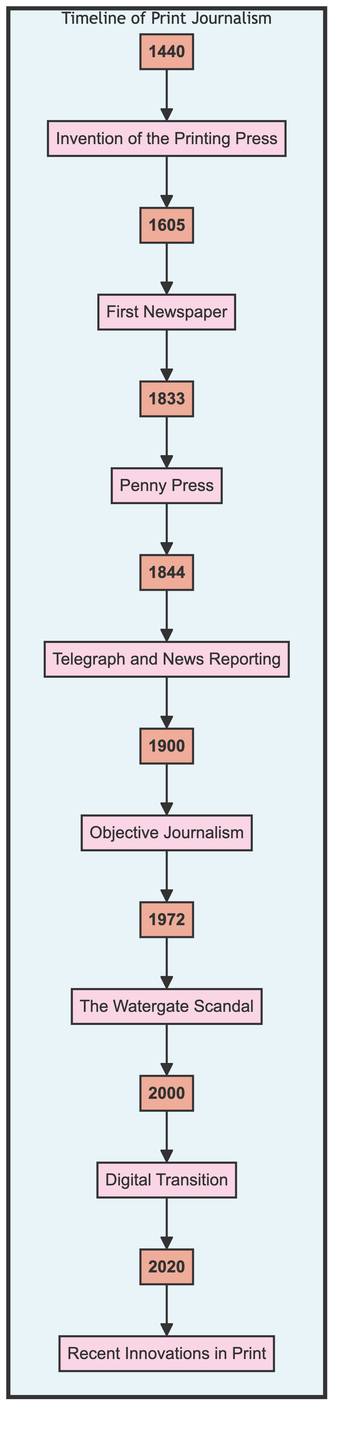What is the first event listed in the timeline? The first event is labeled "Invention of the Printing Press," which is connected to the year 1440 at the start of the flow chart.
Answer: Invention of the Printing Press Which year corresponds to the event "Penny Press"? Looking at the arrow leading to "Penny Press," it is connected to the year 1833, which is clearly indicated in the flow chart.
Answer: 1833 How many major events are shown in the timeline? By counting the events listed from "Invention of the Printing Press" to "Recent Innovations in Print," there are a total of 8 events shown in the flow chart.
Answer: 8 What event occurs directly after the "Telegraph and News Reporting"? Following the event "Telegraph and News Reporting," the next event in sequence is "Objective Journalism," which is directly connected in the flow of the diagram.
Answer: Objective Journalism What year did the event "Digital Transition" take place? In the diagram, "Digital Transition" is connected to the year 2000, which is clear as the node is directly linked to that year.
Answer: 2000 Which event is described as leading to changes in the nature of news reporting in America? The "Watergate Scandal" is depicted in the diagram as a pivotal moment in investigative journalism, indicating a significant change in how news reporting was conducted in America.
Answer: The Watergate Scandal List two events that occurred in the 19th century. The flow chart illustrates "Penny Press" in 1833 and "Telegraph and News Reporting" in 1844 as events that took place in the 19th century, both belonging to that specific range.
Answer: Penny Press, Telegraph and News Reporting What type of journalism began to emerge around the year 1900? The timeline notes that "Objective Journalism" began to emerge around the year 1900 as a significant development in the field of journalism.
Answer: Objective Journalism What significant technological transition is noted to begin around the year 2000? The diagram indicates that a "Digital Transition" began around the year 2000, marking a shift in how journalism was consumed and delivered.
Answer: Digital Transition 